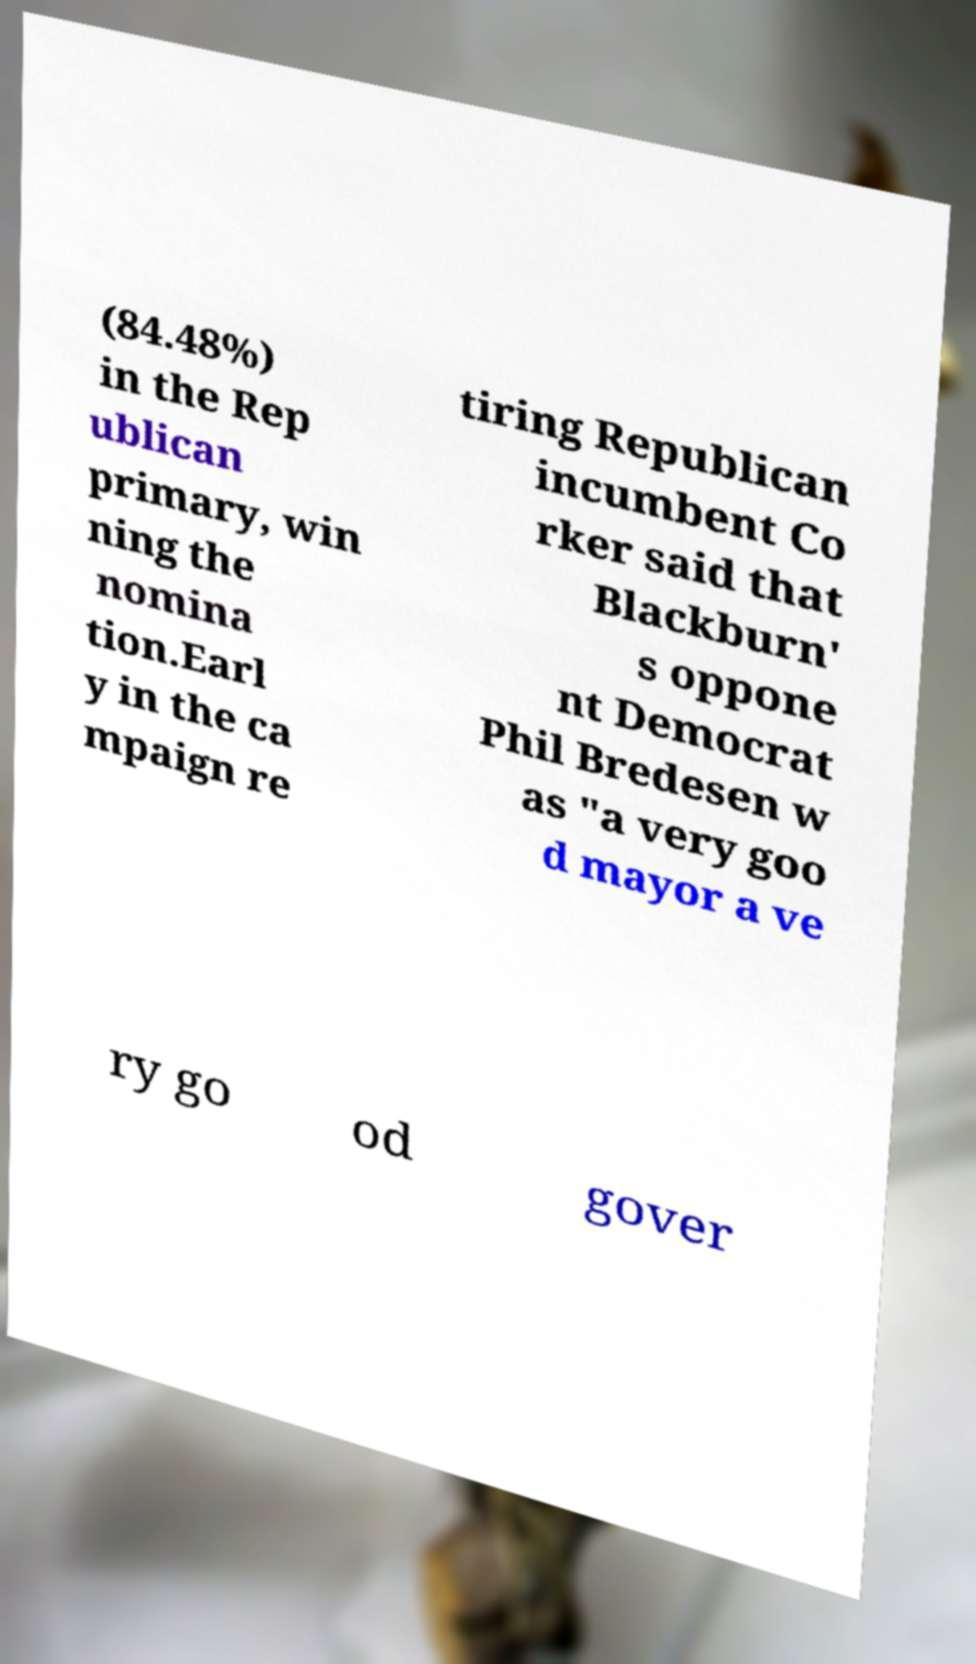For documentation purposes, I need the text within this image transcribed. Could you provide that? (84.48%) in the Rep ublican primary, win ning the nomina tion.Earl y in the ca mpaign re tiring Republican incumbent Co rker said that Blackburn' s oppone nt Democrat Phil Bredesen w as "a very goo d mayor a ve ry go od gover 